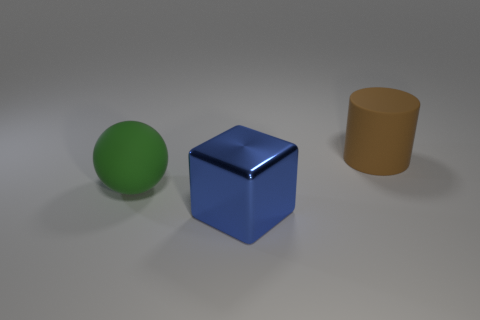What number of metallic things are either green spheres or brown cylinders?
Your answer should be very brief. 0. There is a block that is in front of the large matte object that is in front of the big cylinder; what is its material?
Your answer should be compact. Metal. What shape is the blue shiny object that is the same size as the green rubber sphere?
Offer a very short reply. Cube. Are there fewer blue things than matte things?
Offer a terse response. Yes. There is a big rubber thing that is on the left side of the brown cylinder; are there any large blue shiny blocks that are in front of it?
Keep it short and to the point. Yes. The other object that is the same material as the green object is what shape?
Your response must be concise. Cylinder. There is a big rubber thing on the right side of the large green rubber object; does it have the same shape as the large metal thing?
Give a very brief answer. No. How many other objects are there of the same shape as the big brown thing?
Provide a short and direct response. 0. There is a big matte thing to the right of the ball; what is its shape?
Ensure brevity in your answer.  Cylinder. Is there a tiny red cylinder made of the same material as the big brown thing?
Provide a succinct answer. No. 